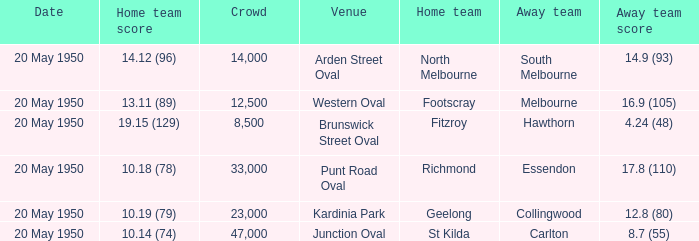Can you give me this table as a dict? {'header': ['Date', 'Home team score', 'Crowd', 'Venue', 'Home team', 'Away team', 'Away team score'], 'rows': [['20 May 1950', '14.12 (96)', '14,000', 'Arden Street Oval', 'North Melbourne', 'South Melbourne', '14.9 (93)'], ['20 May 1950', '13.11 (89)', '12,500', 'Western Oval', 'Footscray', 'Melbourne', '16.9 (105)'], ['20 May 1950', '19.15 (129)', '8,500', 'Brunswick Street Oval', 'Fitzroy', 'Hawthorn', '4.24 (48)'], ['20 May 1950', '10.18 (78)', '33,000', 'Punt Road Oval', 'Richmond', 'Essendon', '17.8 (110)'], ['20 May 1950', '10.19 (79)', '23,000', 'Kardinia Park', 'Geelong', 'Collingwood', '12.8 (80)'], ['20 May 1950', '10.14 (74)', '47,000', 'Junction Oval', 'St Kilda', 'Carlton', '8.7 (55)']]} What was the score for the away team that played against Richmond and has a crowd over 12,500? 17.8 (110). 